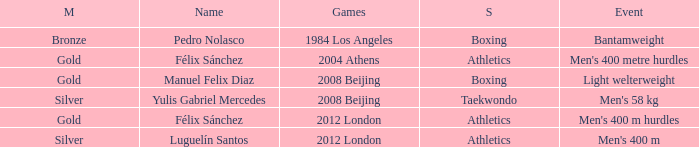Which Medal had a Name of félix sánchez, and a Games of 2012 london? Gold. 